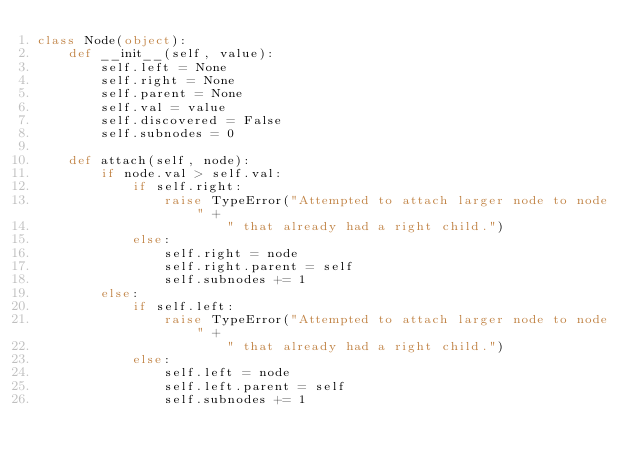<code> <loc_0><loc_0><loc_500><loc_500><_Python_>class Node(object):
    def __init__(self, value):
        self.left = None
        self.right = None
        self.parent = None
        self.val = value
        self.discovered = False
        self.subnodes = 0

    def attach(self, node):
        if node.val > self.val:
            if self.right:
                raise TypeError("Attempted to attach larger node to node" +
                        " that already had a right child.")
            else:
                self.right = node
                self.right.parent = self
                self.subnodes += 1
        else:
            if self.left:
                raise TypeError("Attempted to attach larger node to node" +
                        " that already had a right child.")
            else:
                self.left = node
                self.left.parent = self
                self.subnodes += 1

</code> 